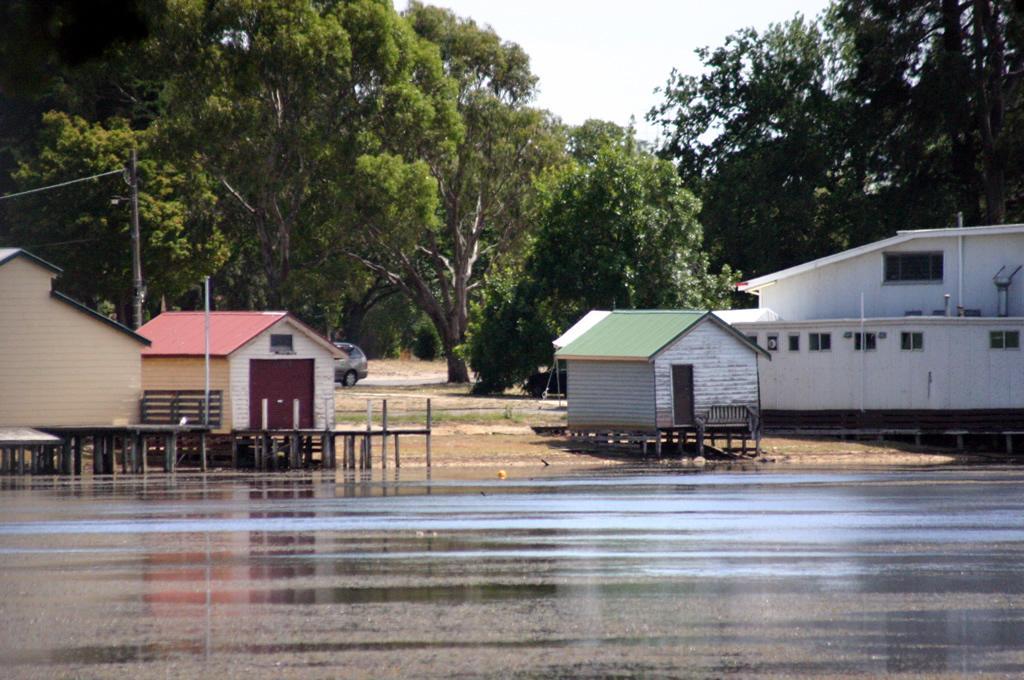How would you summarize this image in a sentence or two? In the center of the image we can see houses and buildings. At the bottom of the image there is water. In the background we can see road, vehicle, pole, trees and sky. 